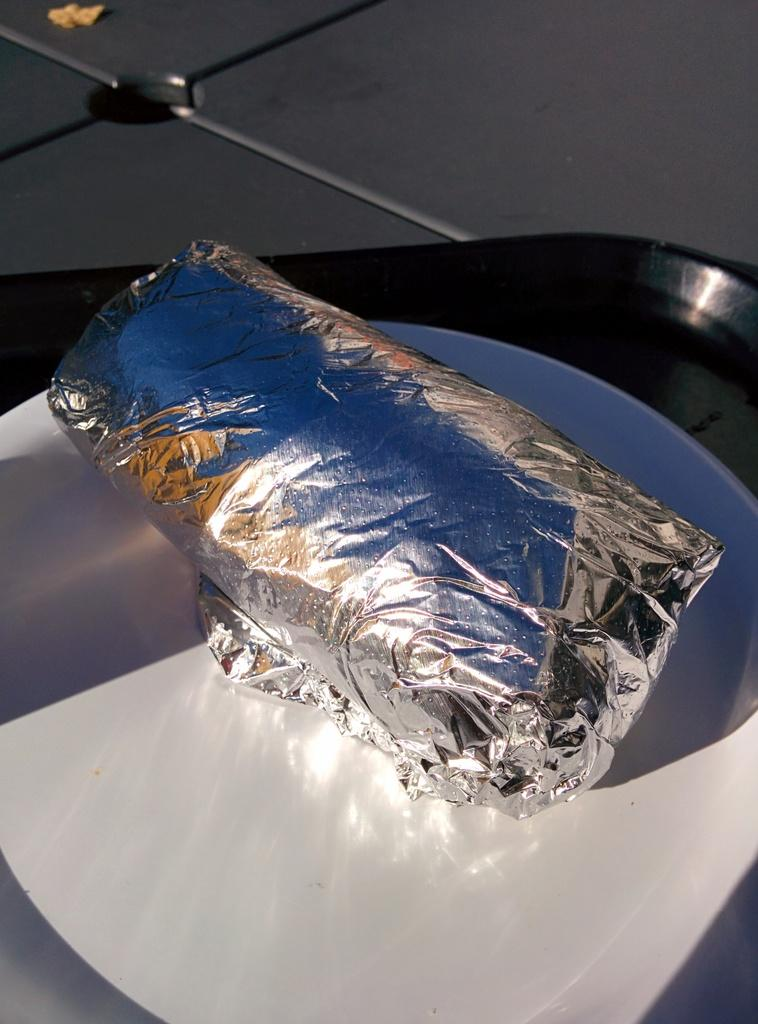What type of material is used for the paper in the image? The paper in the image is made of silver material. How is the silver paper arranged in the image? The silver paper is rolled in the image. Where is the rolled silver paper placed? The rolled silver paper is placed in a plate. What is the plate resting on in the image? The plate is on a tray. What is the tray placed on in the image? The tray is on a platform. What can be seen at the top of the image? There is an object at the top of the image. Reasoning: Let's think step by following the steps to produce the conversation. We start by identifying the main subject in the image, which is the silver paper. Then, we expand the conversation to include details about the arrangement of the silver paper, its placement, and the objects it is resting on. Each question is designed to elicit a specific detail about the image that is known from the provided facts. Absurd Question/Answer: What month is depicted in the image? There is no month depicted in the image; it features a rolled silver paper placed in a plate on a tray. How many fingers can be seen holding the plough in the image? There is no plough or fingers present in the image. 